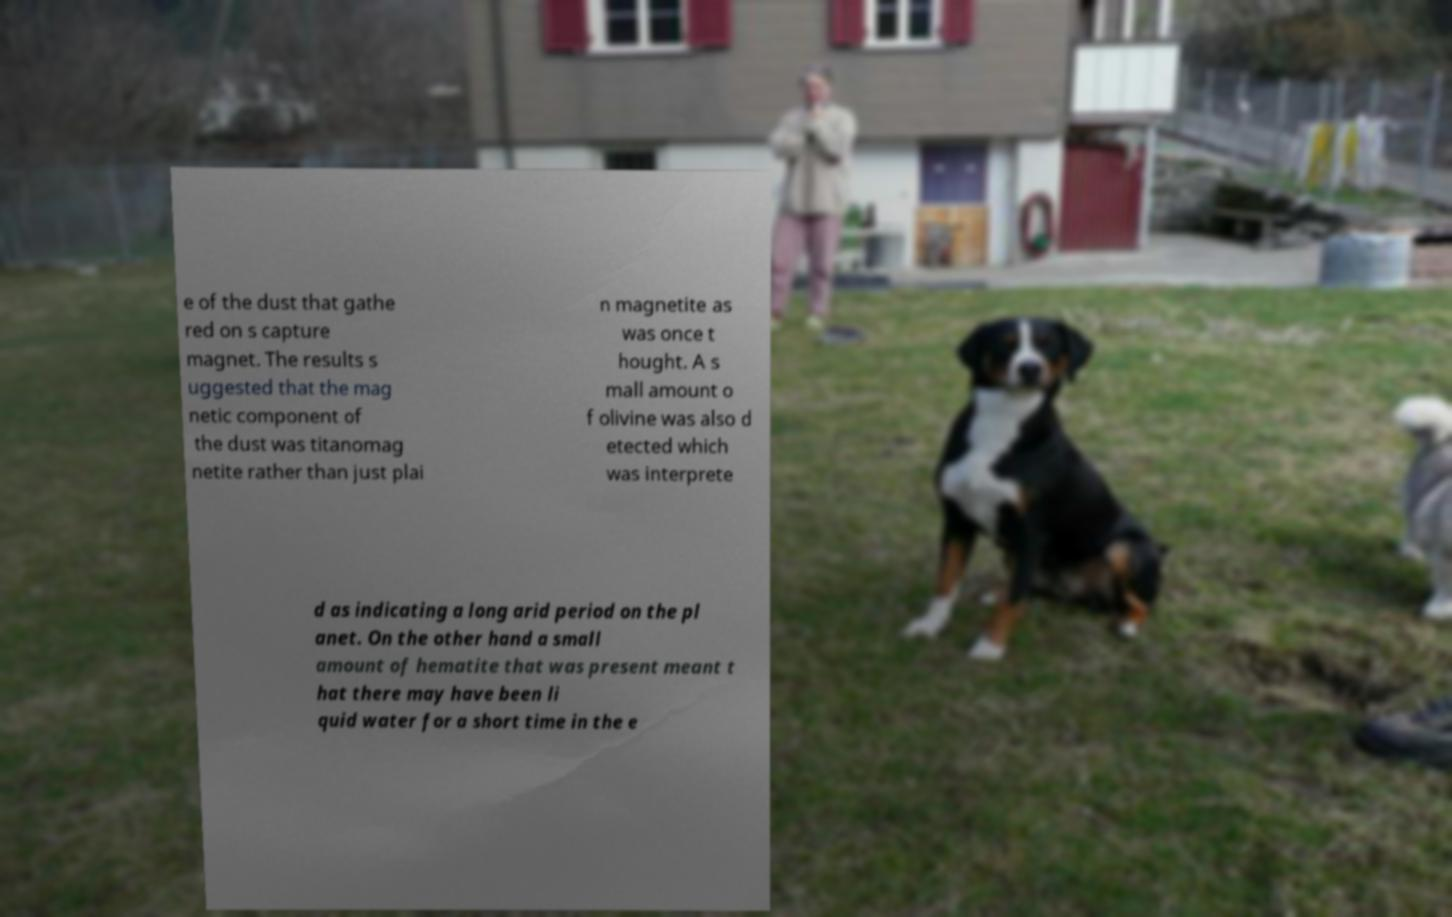Please read and relay the text visible in this image. What does it say? e of the dust that gathe red on s capture magnet. The results s uggested that the mag netic component of the dust was titanomag netite rather than just plai n magnetite as was once t hought. A s mall amount o f olivine was also d etected which was interprete d as indicating a long arid period on the pl anet. On the other hand a small amount of hematite that was present meant t hat there may have been li quid water for a short time in the e 